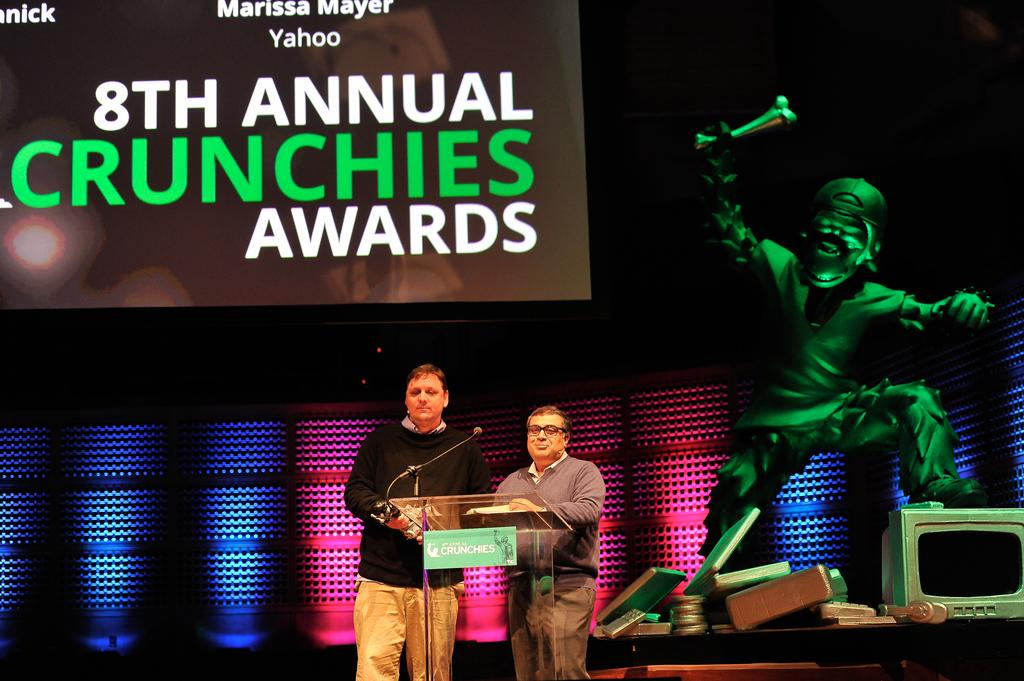<image>
Render a clear and concise summary of the photo. Two men standing on stage at a podium during the 8th Annual Crunchies Awards 